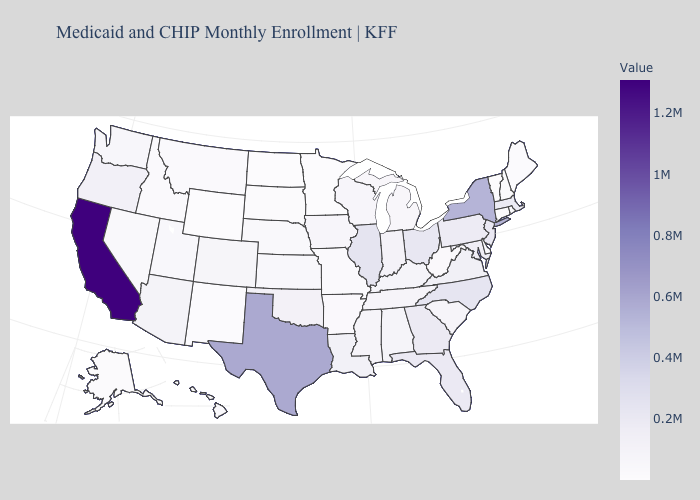Does Texas have the highest value in the South?
Concise answer only. Yes. Does the map have missing data?
Short answer required. No. Does Pennsylvania have a lower value than New York?
Short answer required. Yes. Which states have the lowest value in the MidWest?
Short answer required. Minnesota. Which states hav the highest value in the West?
Concise answer only. California. 